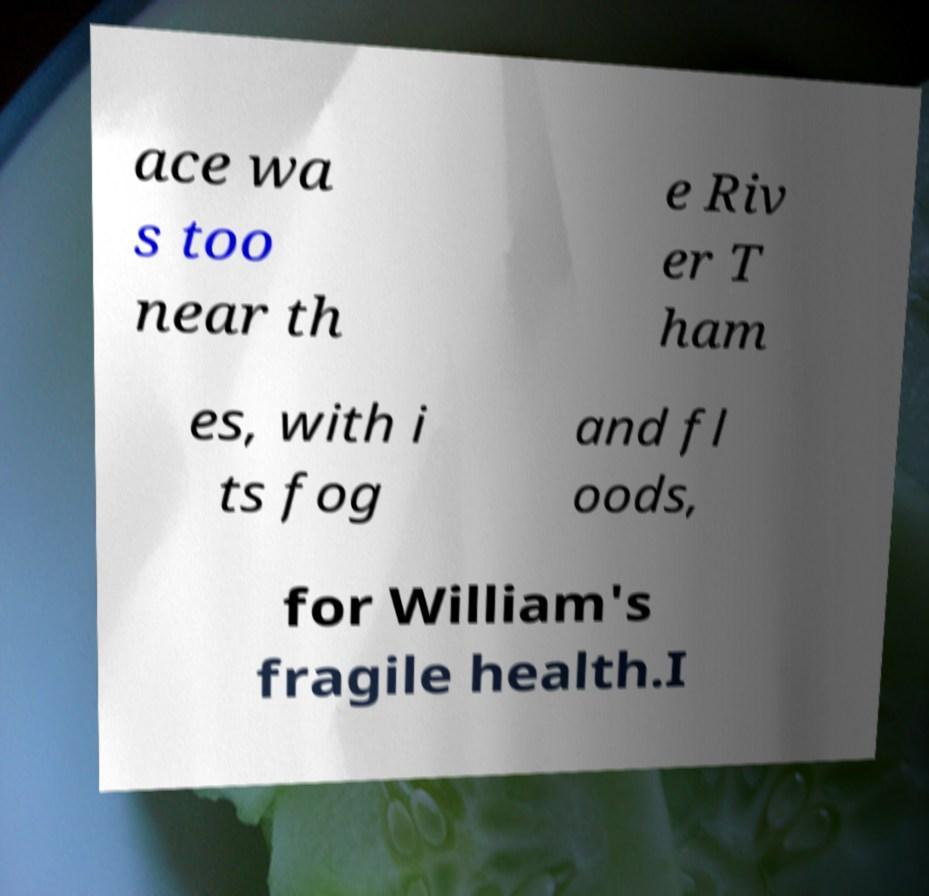What messages or text are displayed in this image? I need them in a readable, typed format. ace wa s too near th e Riv er T ham es, with i ts fog and fl oods, for William's fragile health.I 